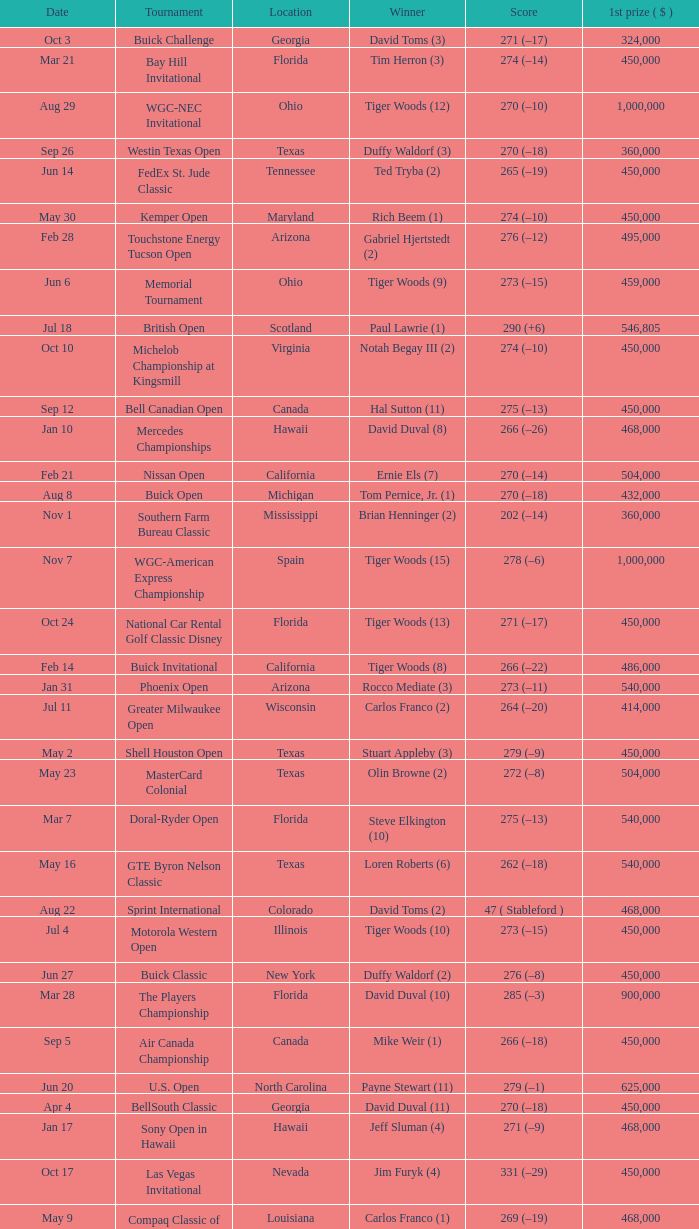What is the score of the B.C. Open in New York? 273 (–15). 